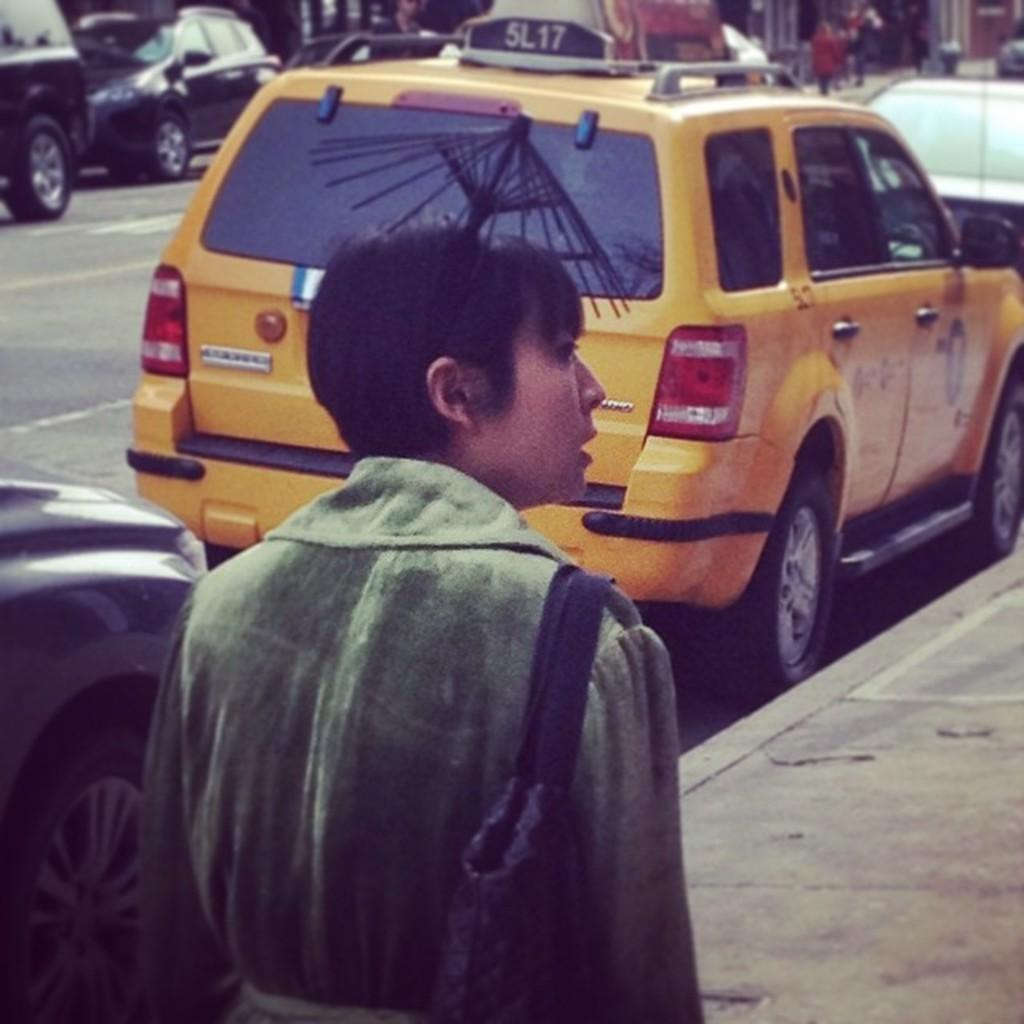Provide a one-sentence caption for the provided image. A person walks on a sidewalk in front of a taxi with a sign that says 5L17 on the roof. 